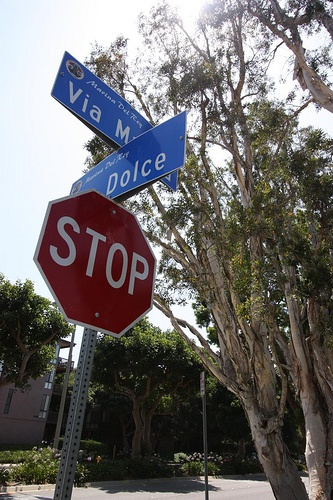Describe the objects in this image and their specific colors. I can see a stop sign in lavender, maroon, and gray tones in this image. 